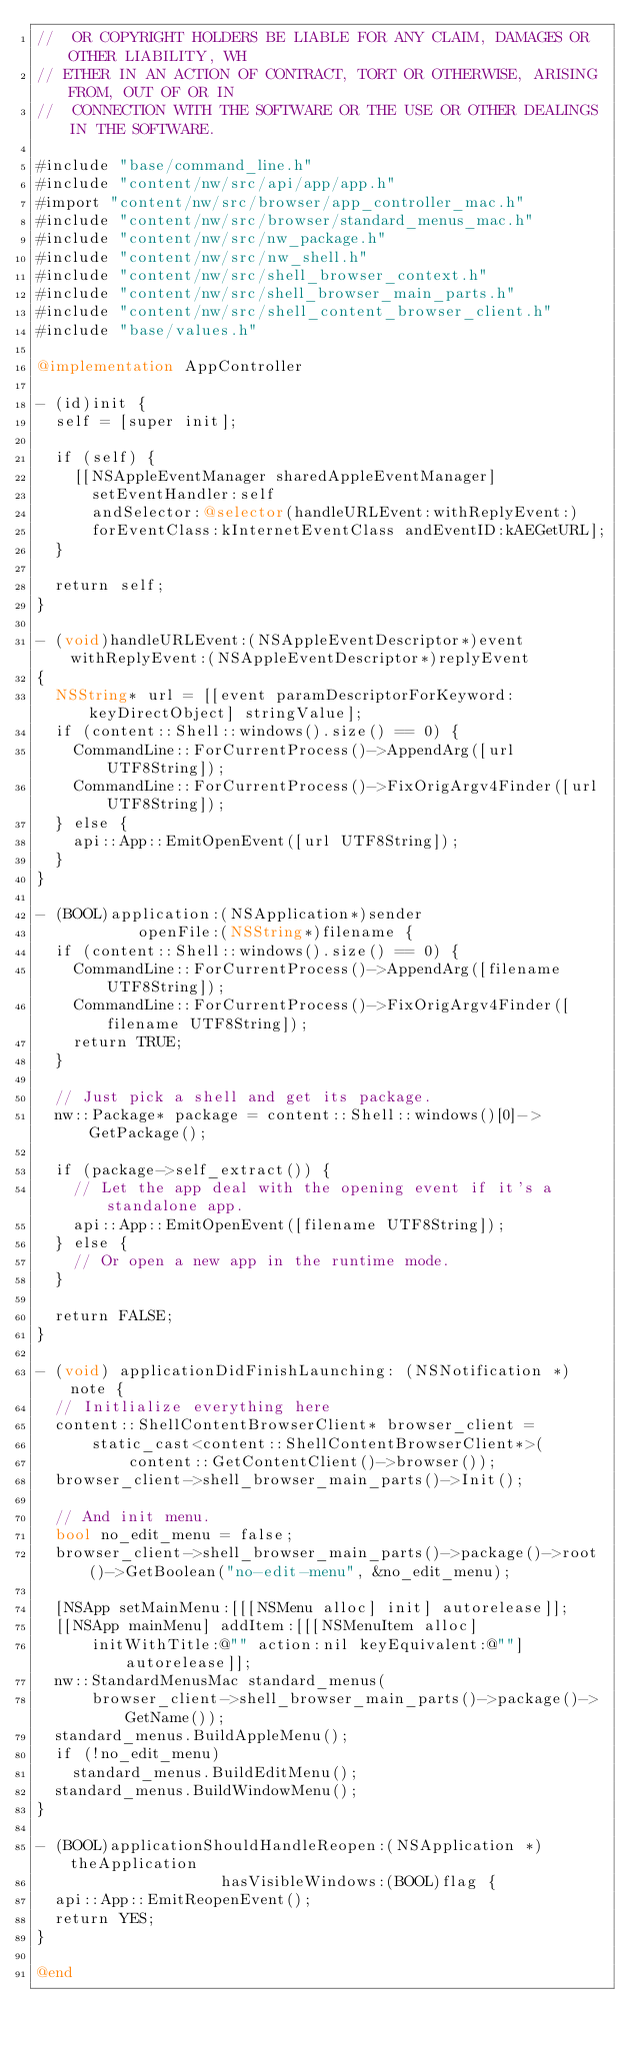<code> <loc_0><loc_0><loc_500><loc_500><_ObjectiveC_>//  OR COPYRIGHT HOLDERS BE LIABLE FOR ANY CLAIM, DAMAGES OR OTHER LIABILITY, WH
// ETHER IN AN ACTION OF CONTRACT, TORT OR OTHERWISE, ARISING FROM, OUT OF OR IN
//  CONNECTION WITH THE SOFTWARE OR THE USE OR OTHER DEALINGS IN THE SOFTWARE.

#include "base/command_line.h"
#include "content/nw/src/api/app/app.h"
#import "content/nw/src/browser/app_controller_mac.h"
#include "content/nw/src/browser/standard_menus_mac.h"
#include "content/nw/src/nw_package.h"
#include "content/nw/src/nw_shell.h"
#include "content/nw/src/shell_browser_context.h"
#include "content/nw/src/shell_browser_main_parts.h"
#include "content/nw/src/shell_content_browser_client.h"
#include "base/values.h"

@implementation AppController

- (id)init {
  self = [super init];

  if (self) {
    [[NSAppleEventManager sharedAppleEventManager]
      setEventHandler:self
      andSelector:@selector(handleURLEvent:withReplyEvent:)
      forEventClass:kInternetEventClass andEventID:kAEGetURL];
  }

  return self;
}

- (void)handleURLEvent:(NSAppleEventDescriptor*)event withReplyEvent:(NSAppleEventDescriptor*)replyEvent
{
  NSString* url = [[event paramDescriptorForKeyword:keyDirectObject] stringValue];
  if (content::Shell::windows().size() == 0) {
    CommandLine::ForCurrentProcess()->AppendArg([url UTF8String]);
    CommandLine::ForCurrentProcess()->FixOrigArgv4Finder([url UTF8String]);
  } else {
    api::App::EmitOpenEvent([url UTF8String]);
  }
}

- (BOOL)application:(NSApplication*)sender
           openFile:(NSString*)filename {
  if (content::Shell::windows().size() == 0) {
    CommandLine::ForCurrentProcess()->AppendArg([filename UTF8String]);
    CommandLine::ForCurrentProcess()->FixOrigArgv4Finder([filename UTF8String]);
    return TRUE;
  }

  // Just pick a shell and get its package.
  nw::Package* package = content::Shell::windows()[0]->GetPackage();

  if (package->self_extract()) {
    // Let the app deal with the opening event if it's a standalone app.
    api::App::EmitOpenEvent([filename UTF8String]);
  } else {
    // Or open a new app in the runtime mode.
  }

  return FALSE;
}

- (void) applicationDidFinishLaunching: (NSNotification *) note {
  // Initlialize everything here
  content::ShellContentBrowserClient* browser_client = 
      static_cast<content::ShellContentBrowserClient*>(
          content::GetContentClient()->browser());
  browser_client->shell_browser_main_parts()->Init();

  // And init menu.
  bool no_edit_menu = false;
  browser_client->shell_browser_main_parts()->package()->root()->GetBoolean("no-edit-menu", &no_edit_menu);

  [NSApp setMainMenu:[[[NSMenu alloc] init] autorelease]];
  [[NSApp mainMenu] addItem:[[[NSMenuItem alloc]
      initWithTitle:@"" action:nil keyEquivalent:@""] autorelease]];
  nw::StandardMenusMac standard_menus(
      browser_client->shell_browser_main_parts()->package()->GetName());
  standard_menus.BuildAppleMenu();
  if (!no_edit_menu)
    standard_menus.BuildEditMenu();
  standard_menus.BuildWindowMenu();
}

- (BOOL)applicationShouldHandleReopen:(NSApplication *)theApplication
                    hasVisibleWindows:(BOOL)flag {
  api::App::EmitReopenEvent();
  return YES;
}

@end
</code> 